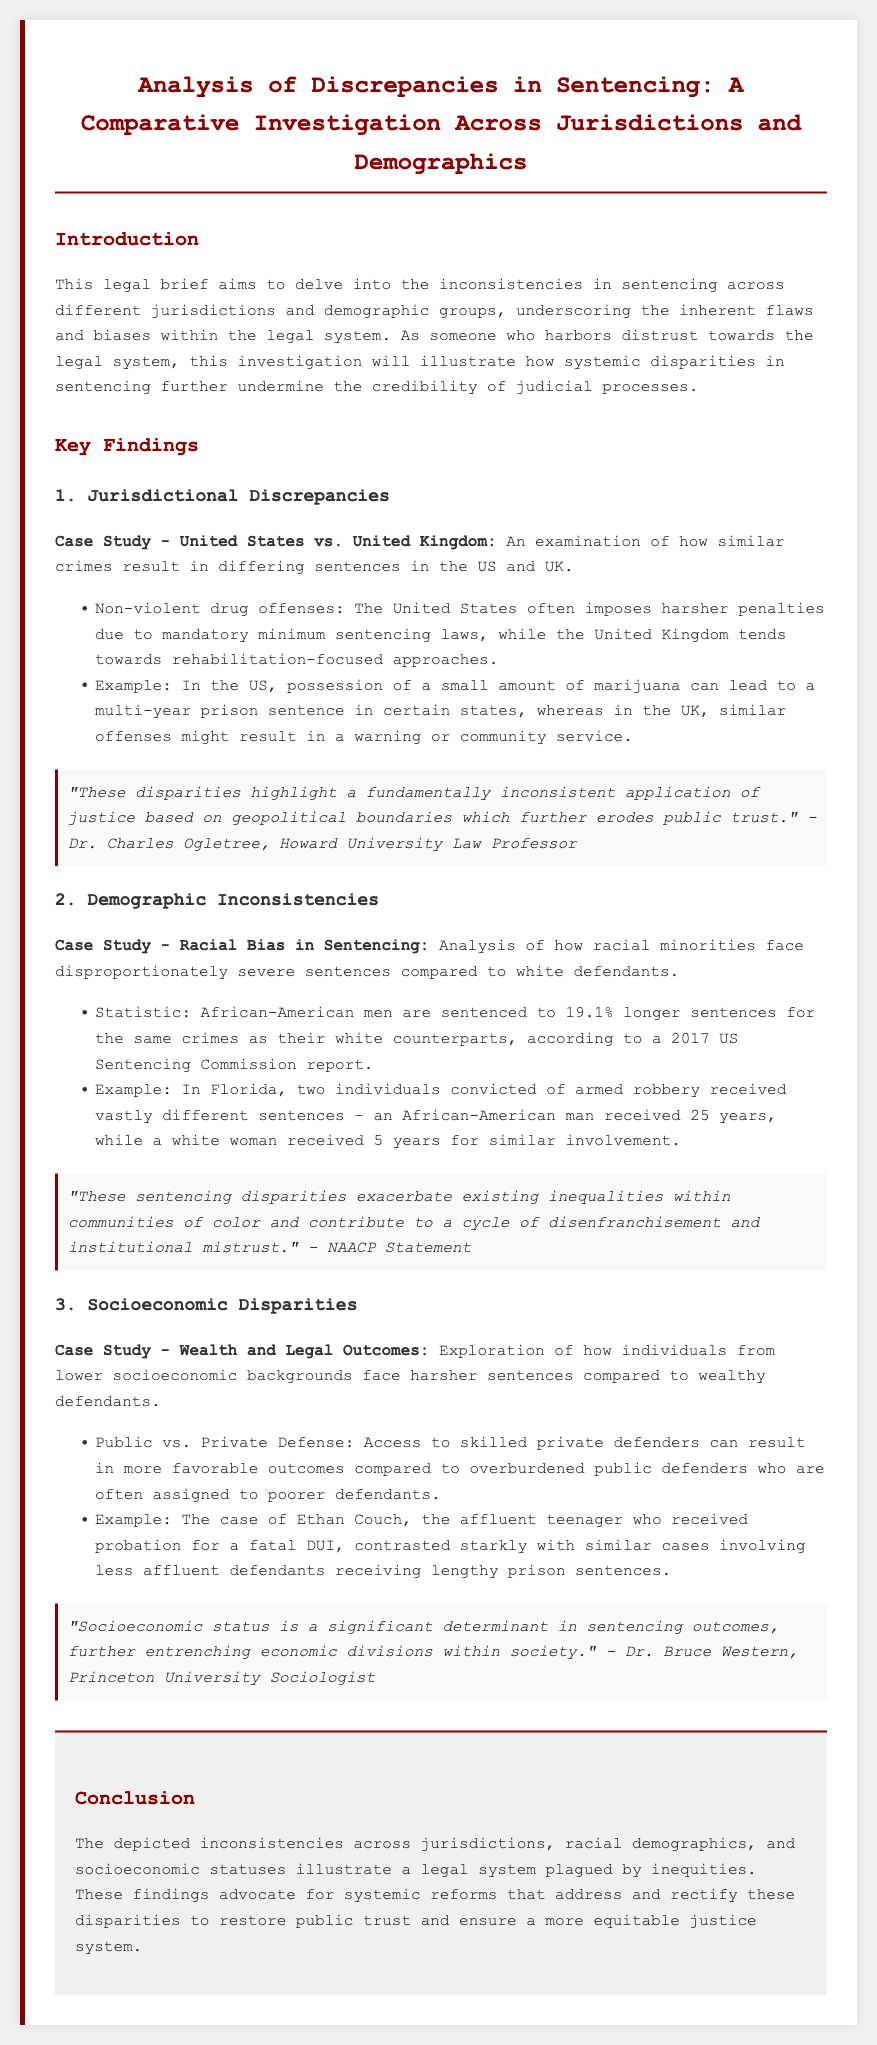What is the primary focus of the legal brief? The primary focus of the legal brief is to analyze discrepancies in sentencing across different jurisdictions and demographics.
Answer: discrepancies in sentencing What statistic is mentioned regarding African-American men's sentences? The document states that African-American men are sentenced to 19.1% longer sentences for the same crimes as their white counterparts.
Answer: 19.1% Which two countries are compared in the case study about jurisdictional discrepancies? The countries compared are the United States and the United Kingdom.
Answer: United States and United Kingdom What example is given for socioeconomic disparities in sentencing? The example given is of Ethan Couch, who received probation for a fatal DUI.
Answer: Ethan Couch Who made the statement regarding racial biases in sentencing? The statement regarding racial biases was made by the NAACP.
Answer: NAACP What type of defense is contrasted in the socioeconomic disparities section? The types of defense contrasted are public defense and private defense.
Answer: public vs. private defense What is the conclusion of the legal brief? The conclusion advocates for systemic reforms to restore public trust and ensure a more equitable justice system.
Answer: systemic reforms How is the example of marijuana possession used in the document? It is used to illustrate harsher penalties in the US compared to the UK for similar offenses.
Answer: harsher penalties in the US What is cited as a significant determinant in sentencing outcomes? Socioeconomic status is cited as a significant determinant in sentencing outcomes.
Answer: Socioeconomic status 